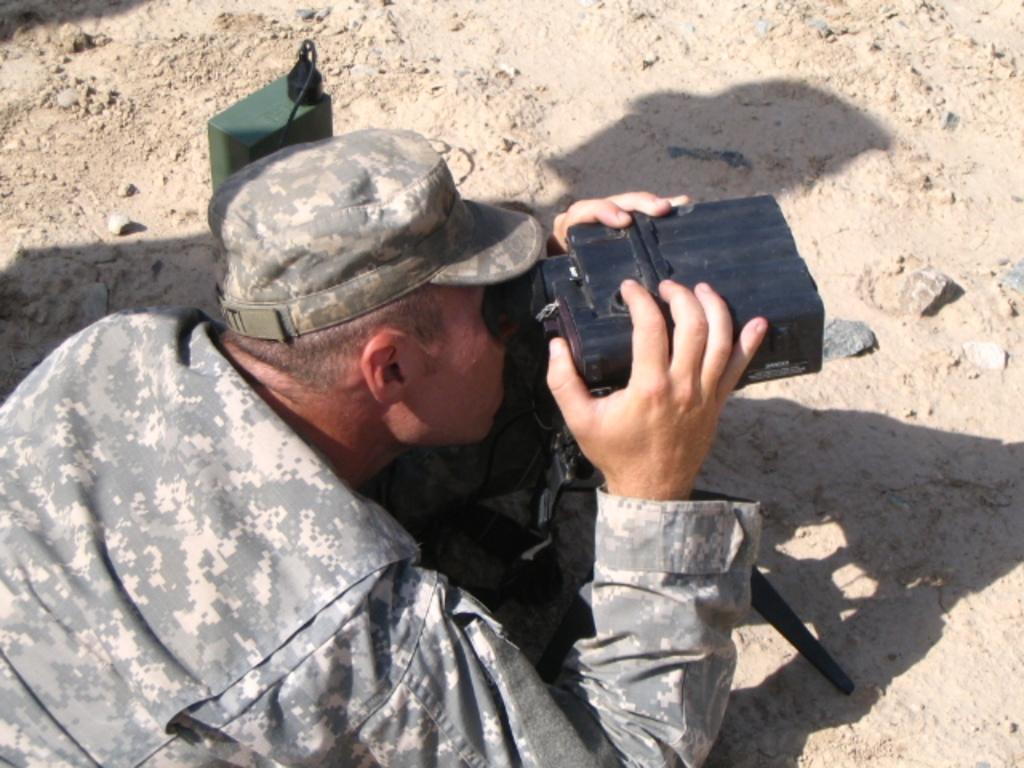Describe this image in one or two sentences. In this picture I can see a man in front who is wearing army uniform and a cap on his head and I see that he is holding an equipment and it is on a tripod and I can see the mud on which there are few stones. On the top left of this picture I can see a black and green color thing. 